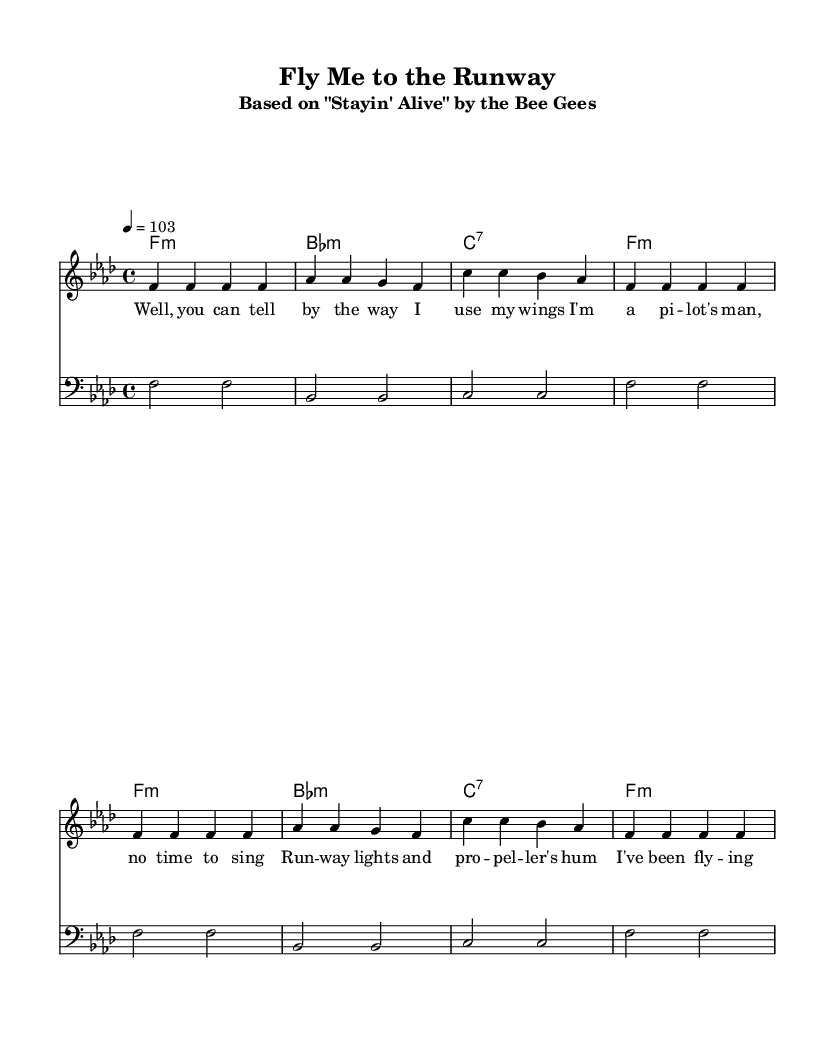What is the key signature of this music? The key signature is indicated by the number of flats or sharps at the beginning of the staff. In this case, there are four flats, which corresponds to F minor.
Answer: F minor What is the time signature of this music? The time signature is found at the beginning of the piece, shown as a fraction. Here, it is indicated as 4 over 4, meaning there are four beats in each measure, and the quarter note gets one beat.
Answer: 4/4 What is the tempo marking for this piece? The tempo marking is noted in beats per minute (BPM) at the beginning of the score, which states "4 = 103". This means that there are 103 beats in one minute and the note value being counted is a quarter note.
Answer: 103 How many measures are there in the melody? To find the number of measures, you can count the vertical lines separating the notes in the melody section. There are 8 measures as counted.
Answer: 8 What is the first line of the lyrics? The first line of the lyrics is located in the lyric mode section beneath the melody staff. It starts with "Well, you can tell by the way I use my wings".
Answer: Well, you can tell by the way I use my wings What type of chords are used in the harmonies section? The chords specified in the harmonies section are indicated in the chord mode, showing minor and dominant seventh chords. The piece starts with an F minor chord followed by B flat minor, C dominant seventh, and back to F minor.
Answer: Minor and seventh chords What is the main theme of the lyrics? The theme can be determined by reading the lyrics, which refer to flying and being a pilot, emphasizing the excitement and experience associated with aviation.
Answer: Aviation and flying 